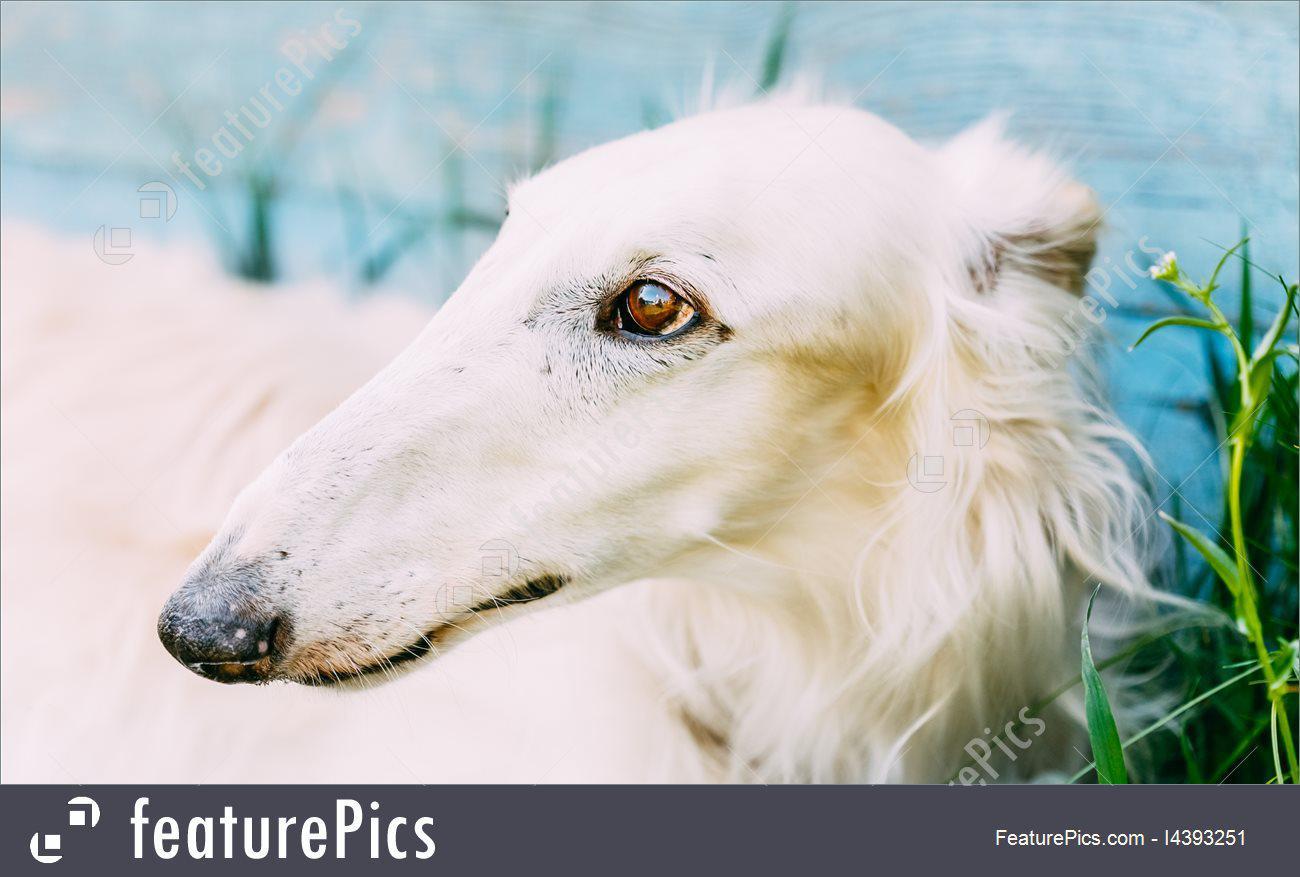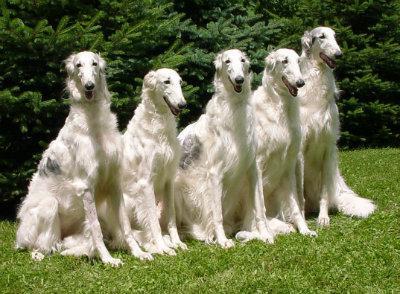The first image is the image on the left, the second image is the image on the right. Analyze the images presented: Is the assertion "There are at most two dogs." valid? Answer yes or no. No. The first image is the image on the left, the second image is the image on the right. Assess this claim about the two images: "At least one of the dogs is near a body of water.". Correct or not? Answer yes or no. Yes. 